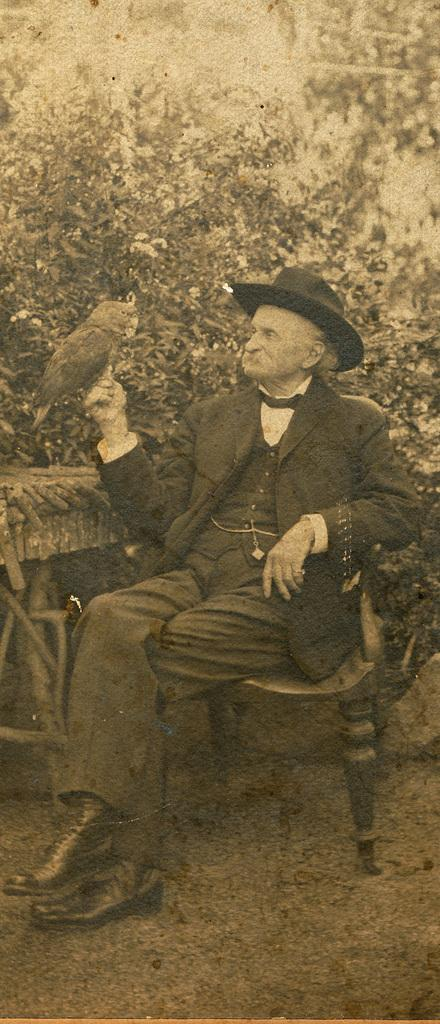What is the main subject of the image? There is a photo in the image. Who or what is in the photo? The photo contains a man. What is the man doing in the photo? The man is sitting on a chair. What is the man wearing in the photo? The man is wearing a hat and a coat. What is the price of the circle in the image? There is no circle or price present in the image. 